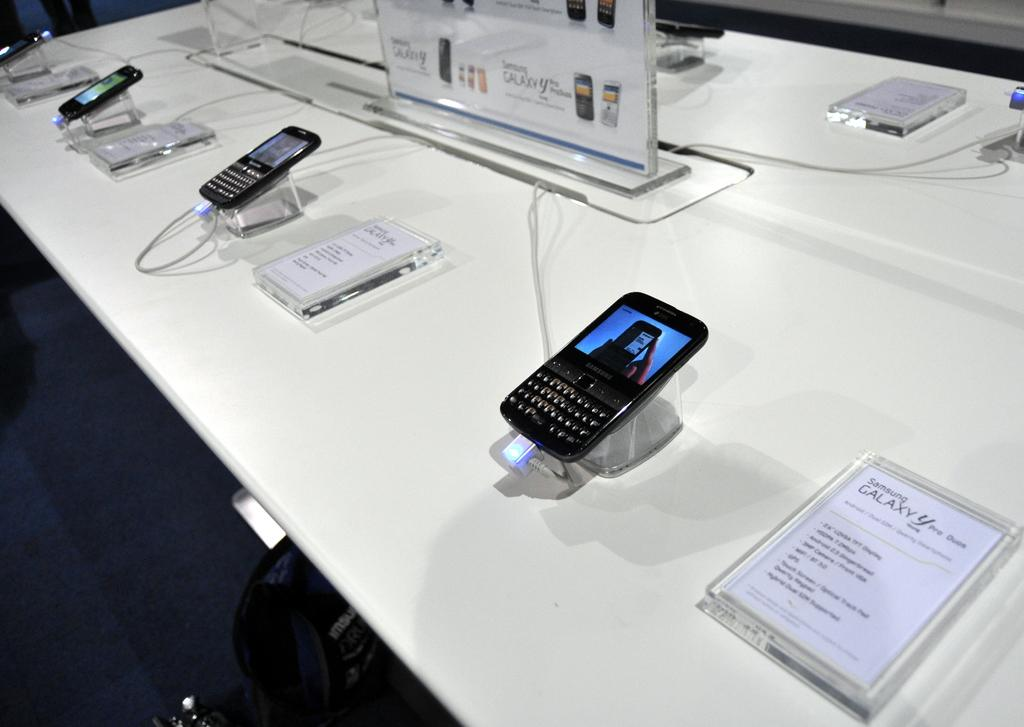<image>
Render a clear and concise summary of the photo. Cellphone on display next to a sign that says Galaxy. 